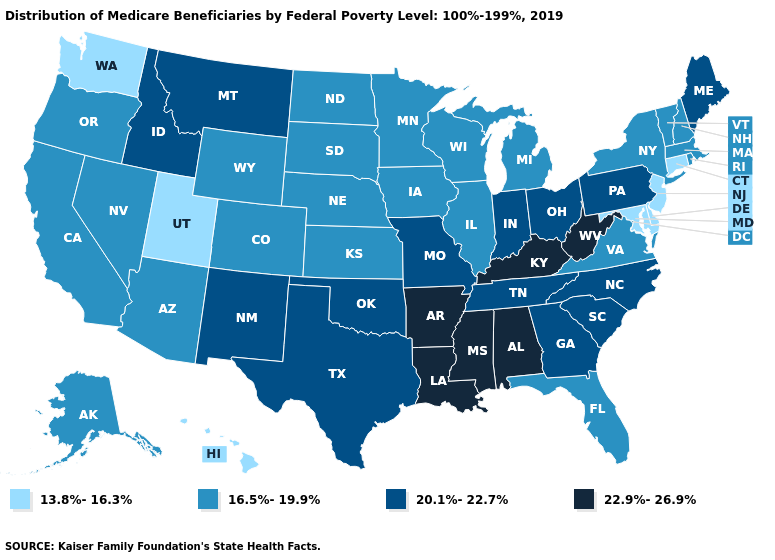Name the states that have a value in the range 13.8%-16.3%?
Short answer required. Connecticut, Delaware, Hawaii, Maryland, New Jersey, Utah, Washington. What is the value of Virginia?
Quick response, please. 16.5%-19.9%. Name the states that have a value in the range 13.8%-16.3%?
Concise answer only. Connecticut, Delaware, Hawaii, Maryland, New Jersey, Utah, Washington. Does the first symbol in the legend represent the smallest category?
Concise answer only. Yes. Which states have the lowest value in the USA?
Write a very short answer. Connecticut, Delaware, Hawaii, Maryland, New Jersey, Utah, Washington. Does Hawaii have the lowest value in the West?
Be succinct. Yes. Name the states that have a value in the range 13.8%-16.3%?
Keep it brief. Connecticut, Delaware, Hawaii, Maryland, New Jersey, Utah, Washington. What is the highest value in the USA?
Write a very short answer. 22.9%-26.9%. Which states have the highest value in the USA?
Write a very short answer. Alabama, Arkansas, Kentucky, Louisiana, Mississippi, West Virginia. How many symbols are there in the legend?
Short answer required. 4. Among the states that border Pennsylvania , which have the highest value?
Quick response, please. West Virginia. Name the states that have a value in the range 22.9%-26.9%?
Concise answer only. Alabama, Arkansas, Kentucky, Louisiana, Mississippi, West Virginia. What is the value of Nevada?
Concise answer only. 16.5%-19.9%. Which states have the lowest value in the Northeast?
Keep it brief. Connecticut, New Jersey. What is the value of Wisconsin?
Quick response, please. 16.5%-19.9%. 